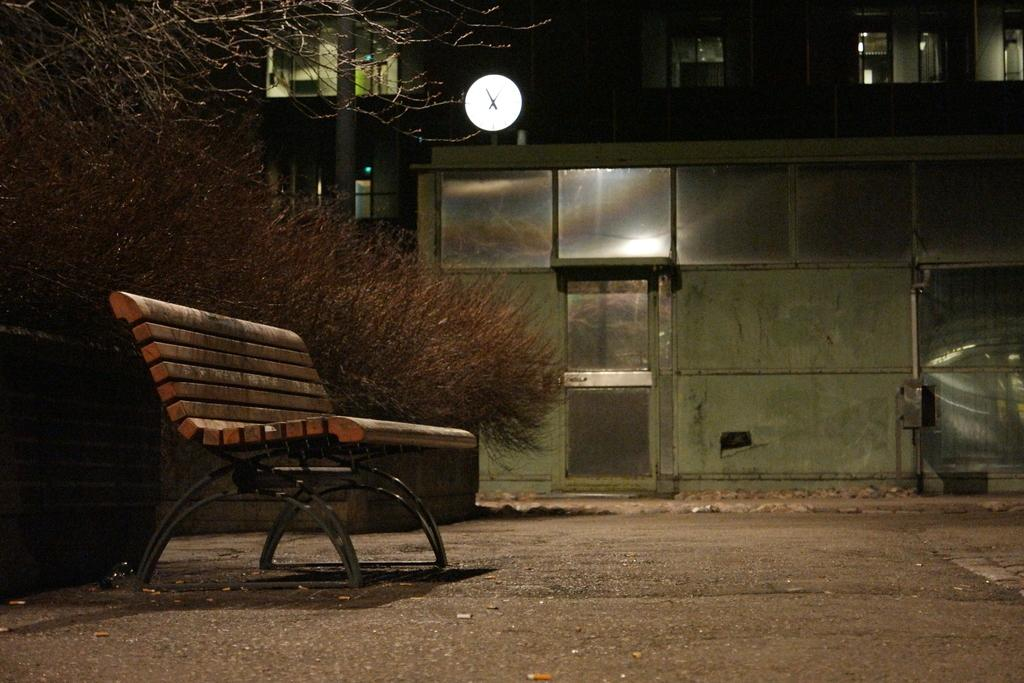What type of structure is present in the image? There is a building in the image. What feature can be seen on the building? The building has a clock. What piece of furniture is visible in the image? There is a table in the image. What type of vegetation is present in the image? There are trees and plants in the image. Can you see a beetle flying with a wing in the image? There is no beetle or wing present in the image. Is there a deer grazing near the trees in the image? There is no deer present in the image; only trees and plants are visible. 